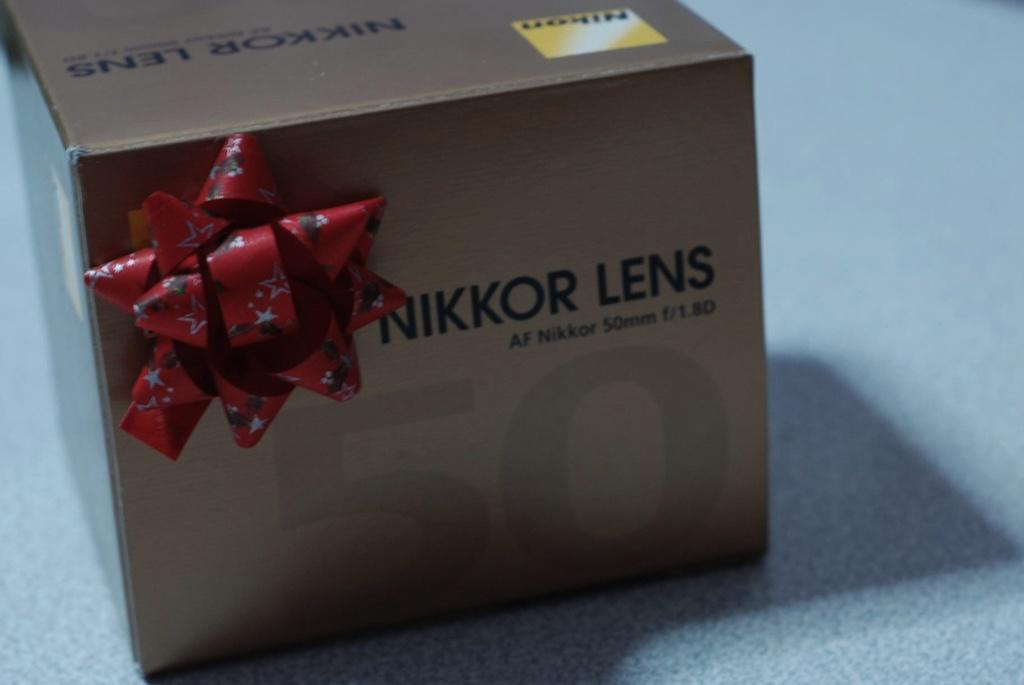<image>
Write a terse but informative summary of the picture. A cardboard box with a bow has the words Nikon and Nikkor Lens written on it. 